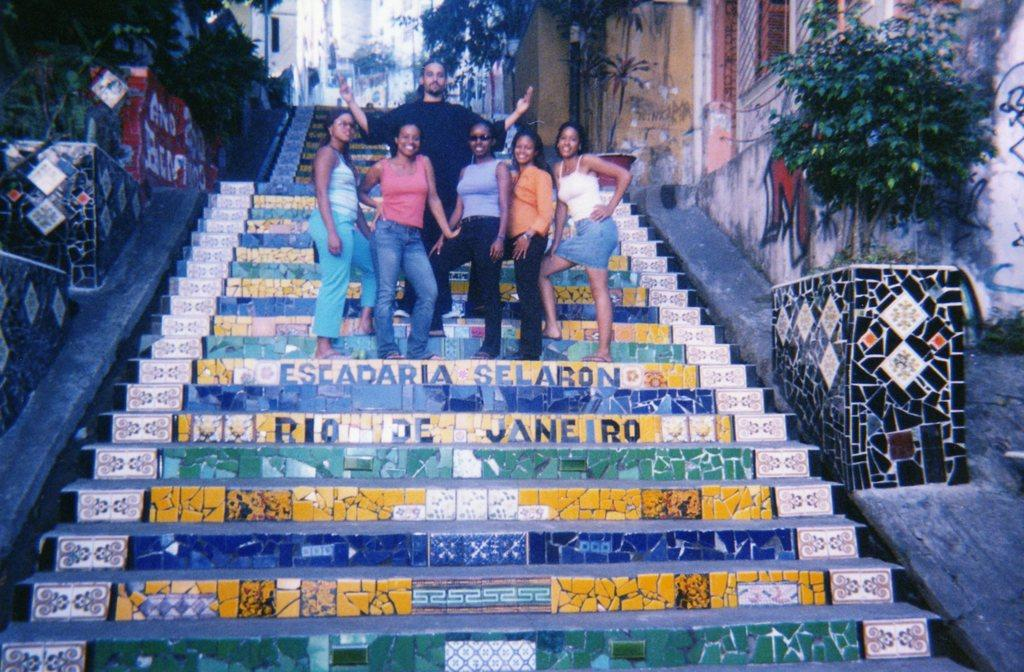What can be seen in the image involving people? There are people standing in the image. What is written on the stairs in the image? There is text on the stairs in the image. What is written on the walls in the image? There is text on the walls in the image. What type of structures are visible in the image? There are houses visible in the image. What type of vegetation is present in the image? There are trees and plants in the image. How many trucks are parked near the houses in the image? There are no trucks visible in the image; only houses, trees, and plants are present. What type of news can be seen on the walls in the image? There is no news present in the image; only text is visible on the walls. 